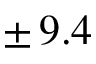<formula> <loc_0><loc_0><loc_500><loc_500>\pm \, 9 . 4</formula> 